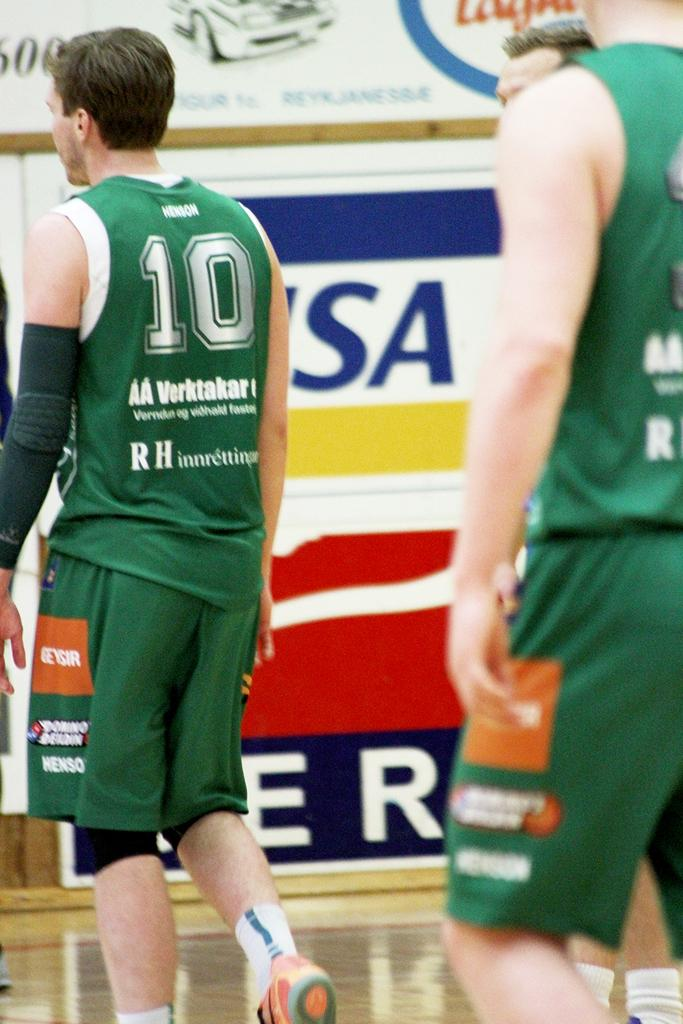<image>
Offer a succinct explanation of the picture presented. Number 10 walks on the court with at least one teammate behind. 